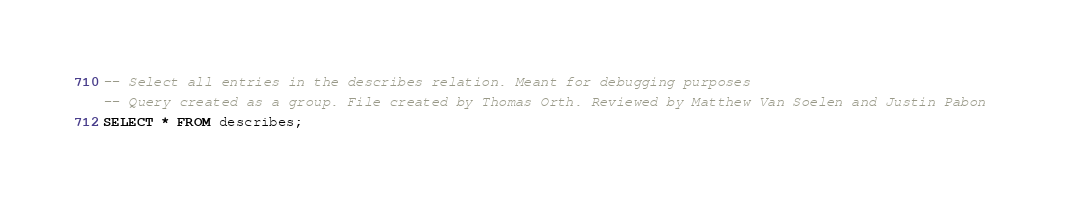Convert code to text. <code><loc_0><loc_0><loc_500><loc_500><_SQL_>-- Select all entries in the describes relation. Meant for debugging purposes
-- Query created as a group. File created by Thomas Orth. Reviewed by Matthew Van Soelen and Justin Pabon 
SELECT * FROM describes;</code> 